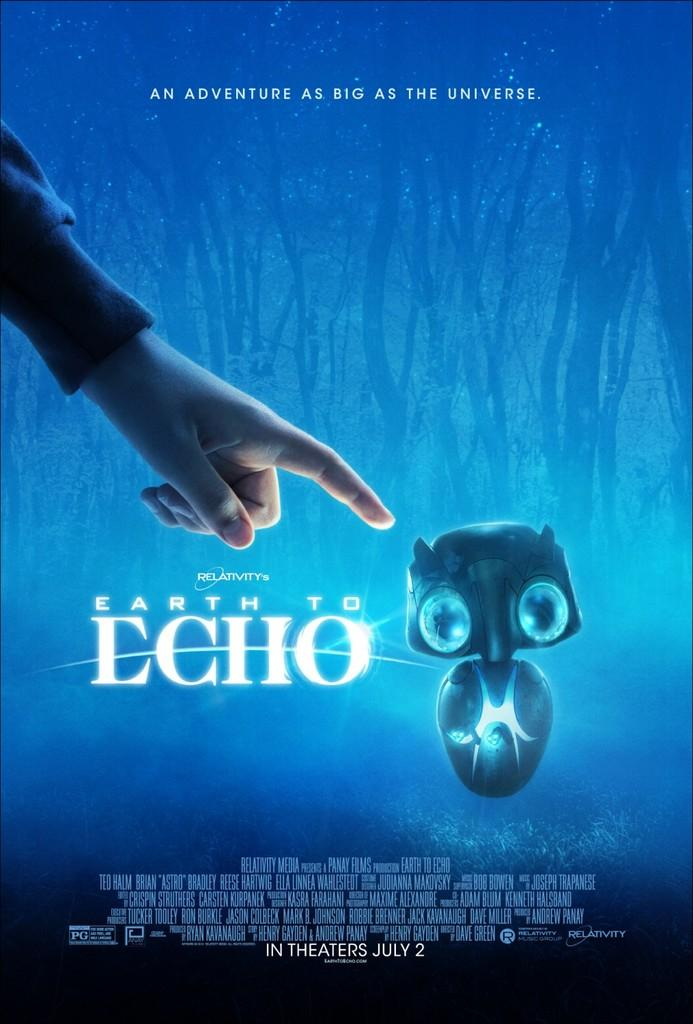<image>
Describe the image concisely. An advertisement for a movie called "earth to echo." 